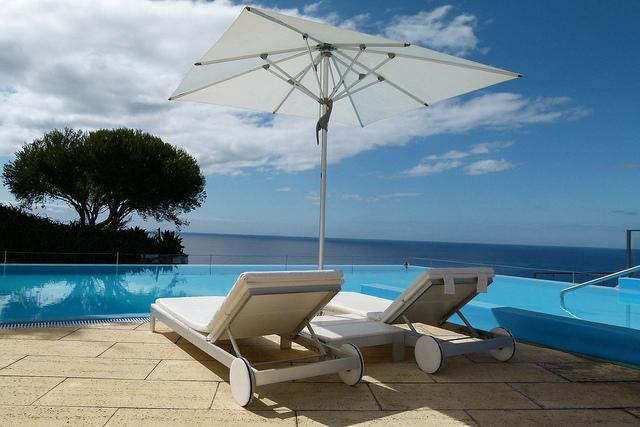What would a person be doing here?

Choices:
A) flying
B) digging
C) burying
D) relaxing relaxing 